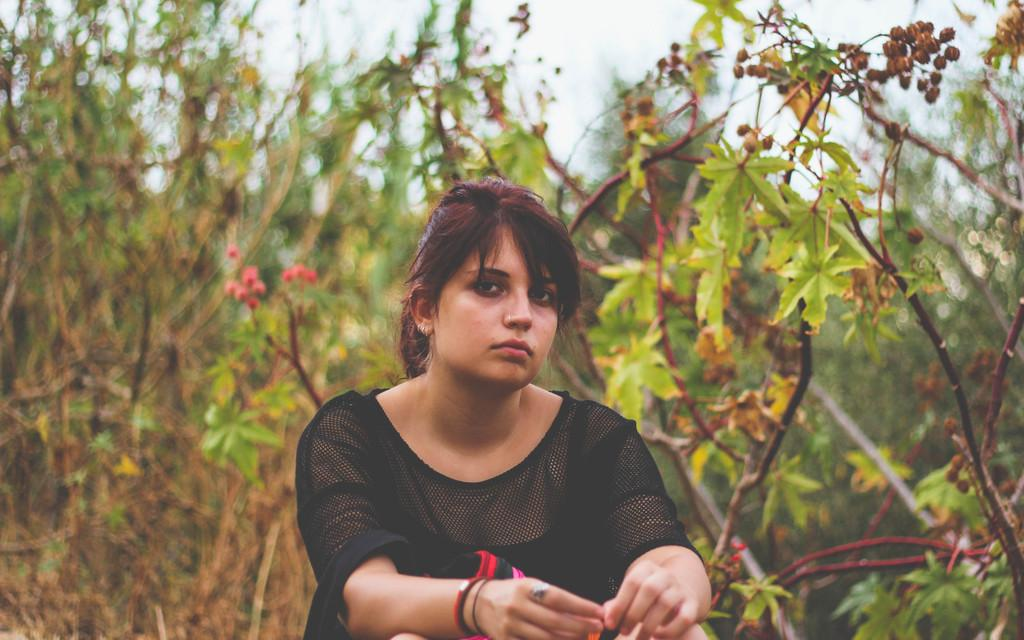What is the main subject in the foreground of the picture? There is a woman in the foreground of the picture. What is the woman wearing in the image? The woman is wearing a black top. What can be seen in the background of the image? There are plants visible in the background of the image. How many bubbles are floating around the woman in the image? There are no bubbles present in the image. Are there any giants visible in the background of the image? There are no giants present in the image. 